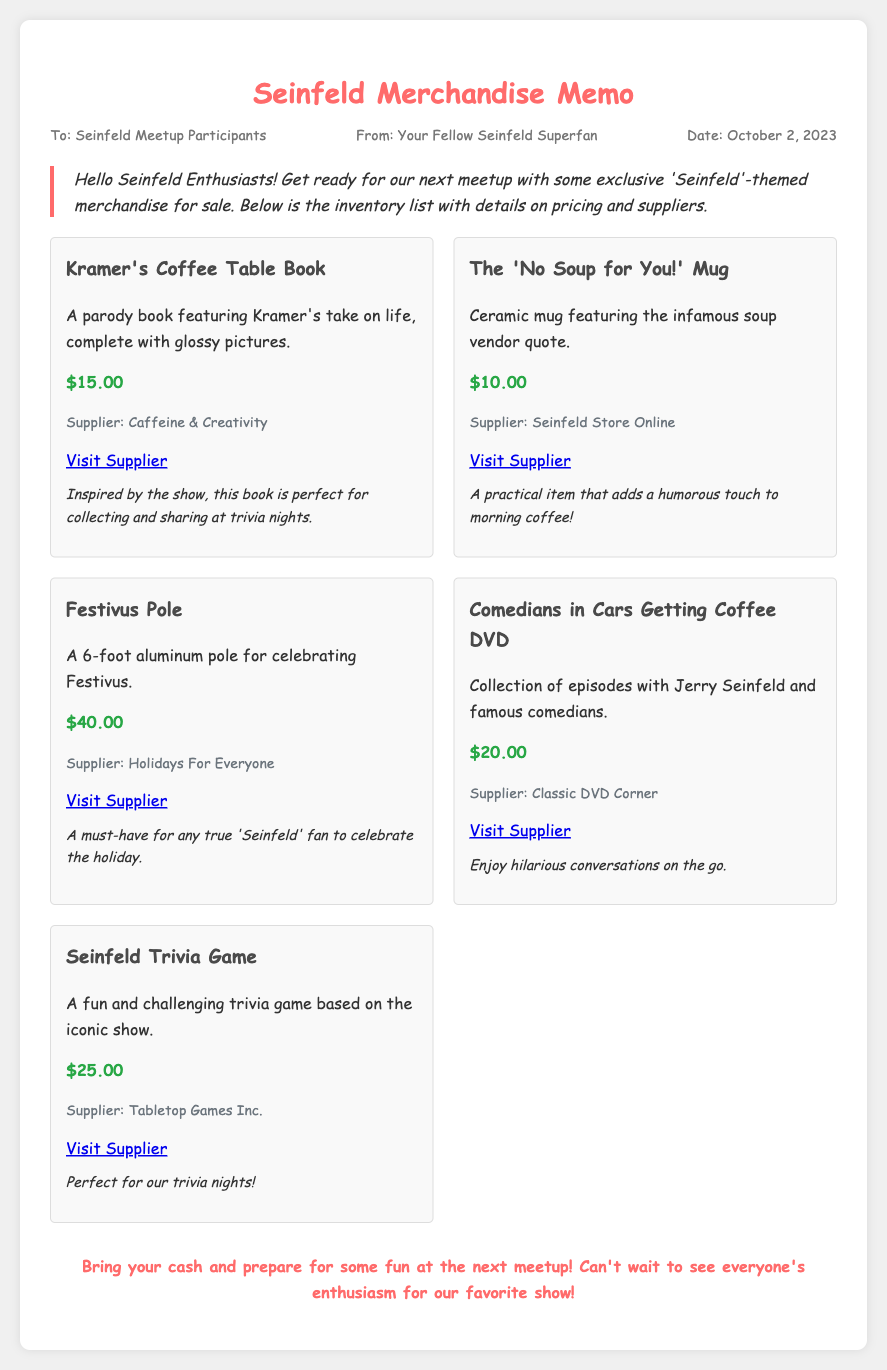What is the price of Kramer's Coffee Table Book? The price of Kramer's Coffee Table Book is specifically mentioned in the inventory list for merchandise.
Answer: $15.00 Who is the supplier for the 'No Soup for You!' Mug? The supplier information for each item is listed alongside the merchandise details.
Answer: Seinfeld Store Online What is the price of the Festivus Pole? The price of the Festivus Pole is included in the inventory list, making it easy to find.
Answer: $40.00 What type of item is the Seinfeld Trivia Game? The type of item refers to its classification as a game designed around the show's content, which is provided in the memo.
Answer: Trivia Game How much does the Comedians in Cars Getting Coffee DVD cost? The cost of the DVD is stated in the inventory list, which clearly outlines the pricing for each item.
Answer: $20.00 What is the theme of the merchandise available at the meetup? The theme is focused on 'Seinfeld', as indicated throughout the memo regarding the merchandise for sale.
Answer: Seinfeld How many items are in the inventory list? The number of items can be counted from the inventory section where each merchandise entry is listed.
Answer: Five What message is emphasized in the footer of the memo? The footer conveys a message about bringing cash and preparing for fun, which captures the spirit of the meetup.
Answer: Bring your cash and prepare for some fun! 